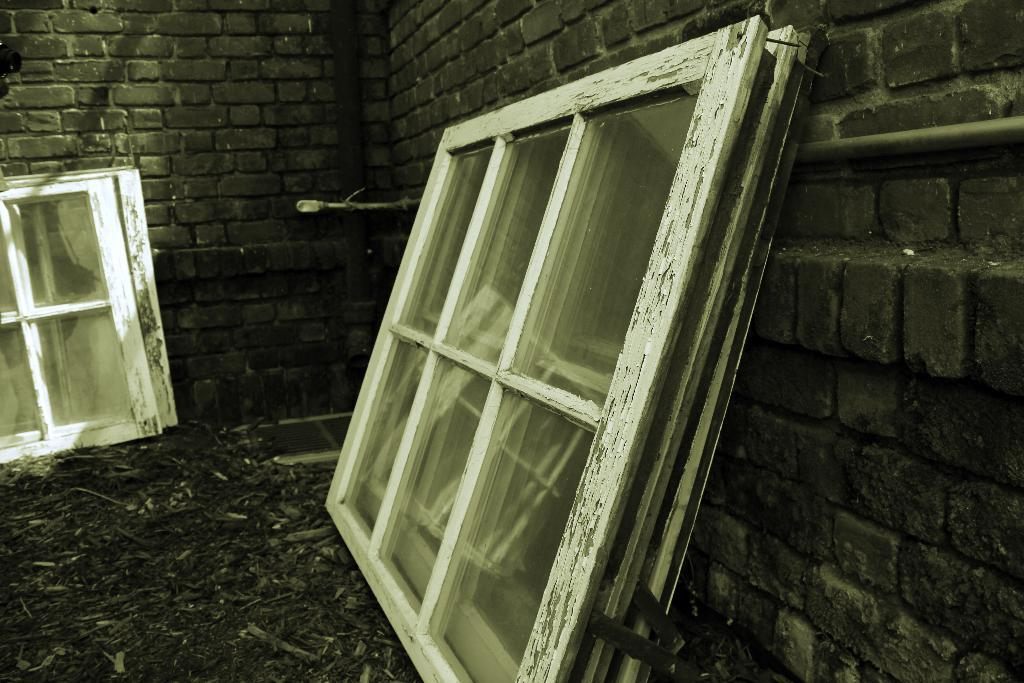What material is used to construct the wall in the image? The wall in the image is made of bricks. What color are the windows in the wall? The windows in the wall are white-colored. What is visible at the bottom of the image? There is a ground at the bottom of the image. What month is depicted in the image? There is no month depicted in the image; it only shows a wall made of bricks, white-colored windows, and a ground. 